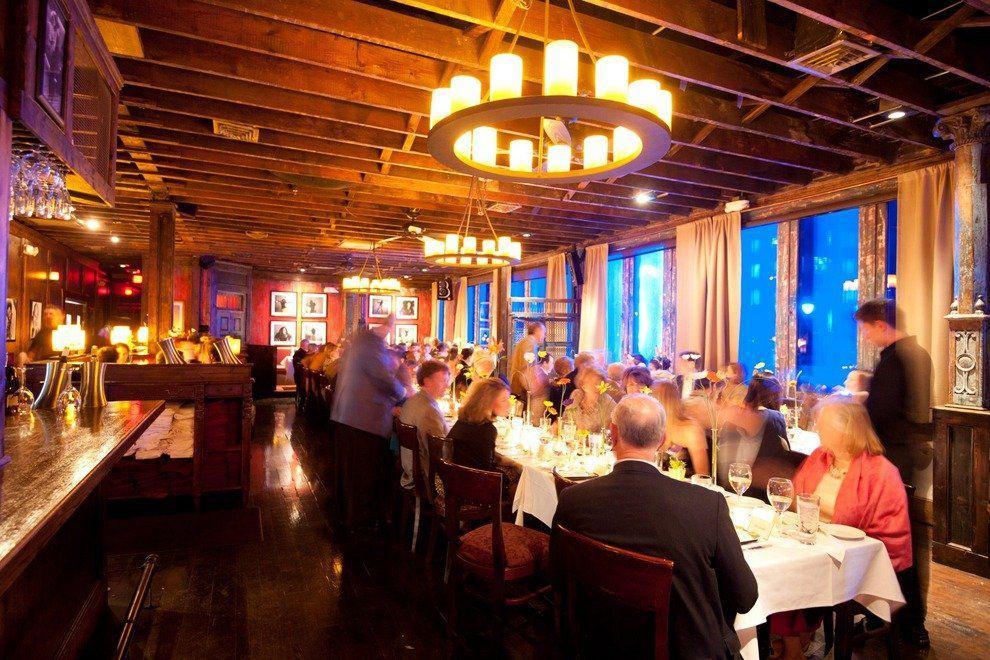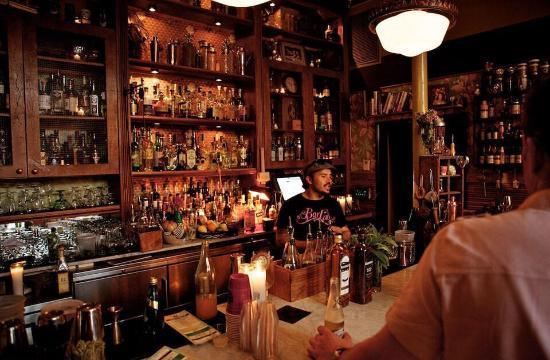The first image is the image on the left, the second image is the image on the right. Analyze the images presented: Is the assertion "In the right image, there's an empty restaurant." valid? Answer yes or no. No. 